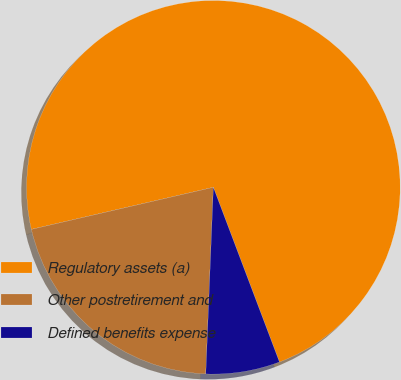Convert chart. <chart><loc_0><loc_0><loc_500><loc_500><pie_chart><fcel>Regulatory assets (a)<fcel>Other postretirement and<fcel>Defined benefits expense<nl><fcel>72.87%<fcel>20.74%<fcel>6.4%<nl></chart> 